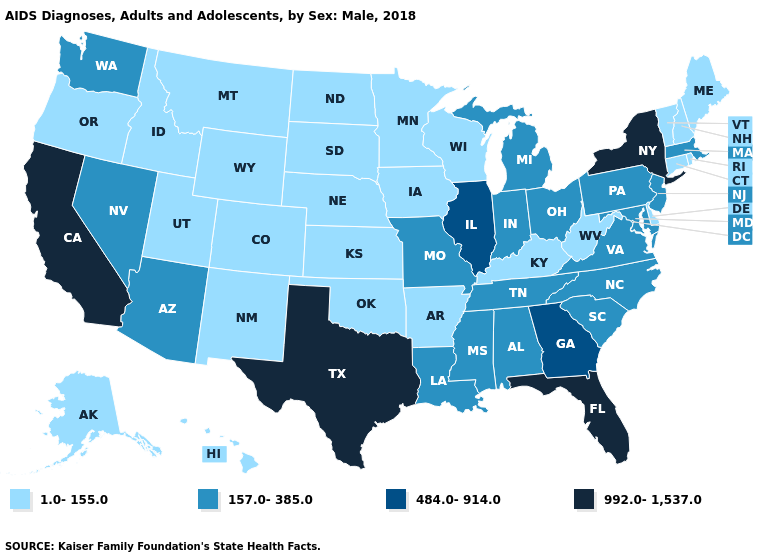Among the states that border Colorado , does Arizona have the highest value?
Keep it brief. Yes. Name the states that have a value in the range 992.0-1,537.0?
Write a very short answer. California, Florida, New York, Texas. Name the states that have a value in the range 992.0-1,537.0?
Short answer required. California, Florida, New York, Texas. What is the value of Montana?
Concise answer only. 1.0-155.0. Name the states that have a value in the range 484.0-914.0?
Write a very short answer. Georgia, Illinois. Which states have the lowest value in the USA?
Concise answer only. Alaska, Arkansas, Colorado, Connecticut, Delaware, Hawaii, Idaho, Iowa, Kansas, Kentucky, Maine, Minnesota, Montana, Nebraska, New Hampshire, New Mexico, North Dakota, Oklahoma, Oregon, Rhode Island, South Dakota, Utah, Vermont, West Virginia, Wisconsin, Wyoming. Among the states that border Ohio , does West Virginia have the lowest value?
Short answer required. Yes. Name the states that have a value in the range 1.0-155.0?
Be succinct. Alaska, Arkansas, Colorado, Connecticut, Delaware, Hawaii, Idaho, Iowa, Kansas, Kentucky, Maine, Minnesota, Montana, Nebraska, New Hampshire, New Mexico, North Dakota, Oklahoma, Oregon, Rhode Island, South Dakota, Utah, Vermont, West Virginia, Wisconsin, Wyoming. What is the value of Arkansas?
Answer briefly. 1.0-155.0. What is the value of Hawaii?
Quick response, please. 1.0-155.0. Among the states that border Michigan , which have the highest value?
Quick response, please. Indiana, Ohio. Among the states that border Pennsylvania , which have the highest value?
Be succinct. New York. Among the states that border Connecticut , which have the highest value?
Give a very brief answer. New York. Among the states that border Maine , which have the lowest value?
Short answer required. New Hampshire. What is the value of Oklahoma?
Short answer required. 1.0-155.0. 